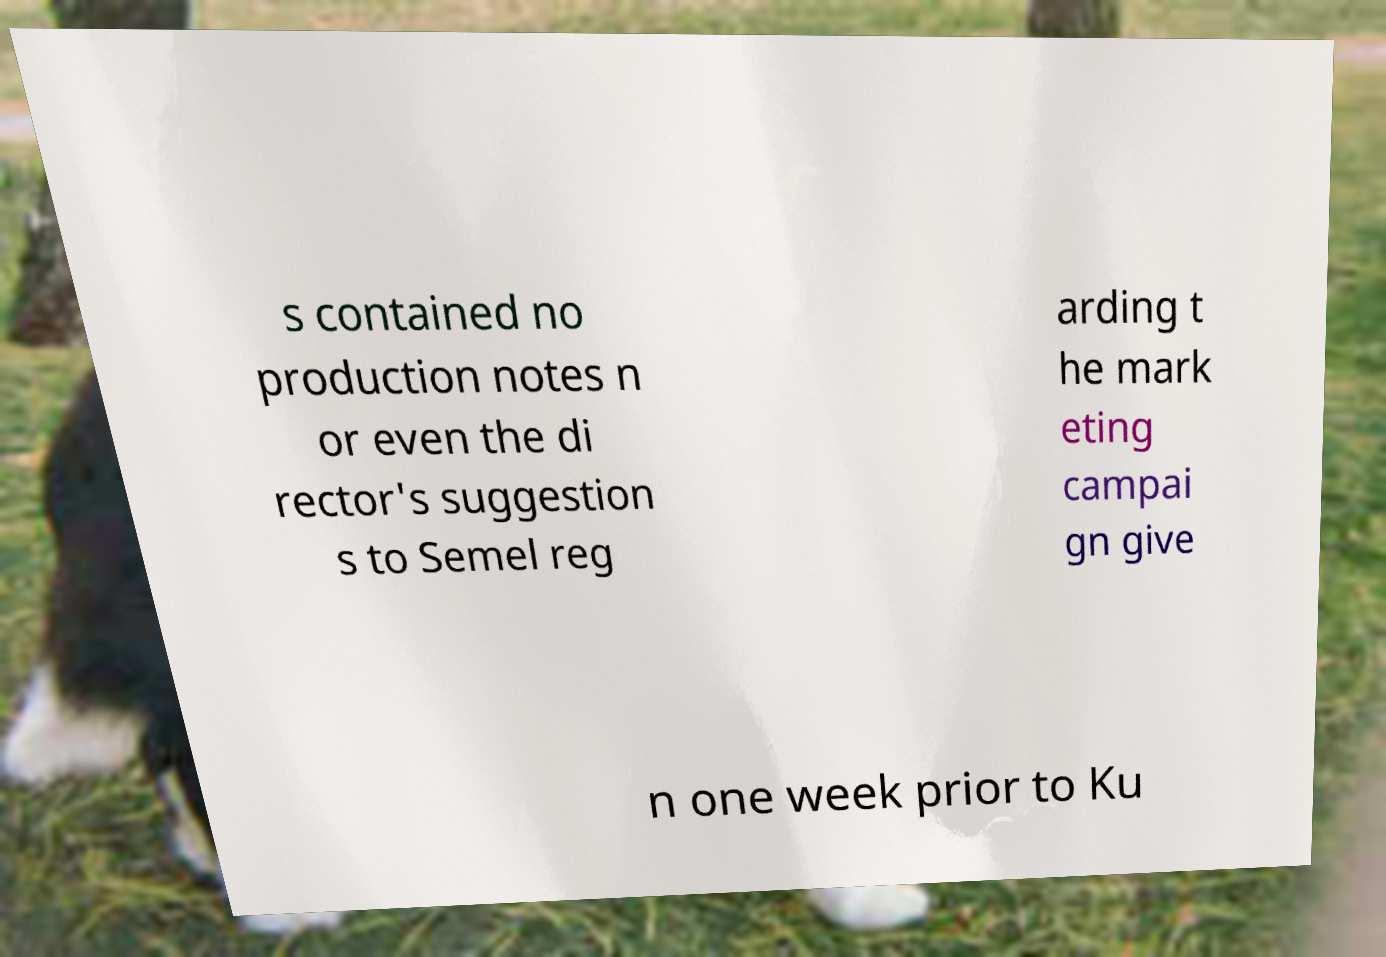Can you accurately transcribe the text from the provided image for me? s contained no production notes n or even the di rector's suggestion s to Semel reg arding t he mark eting campai gn give n one week prior to Ku 